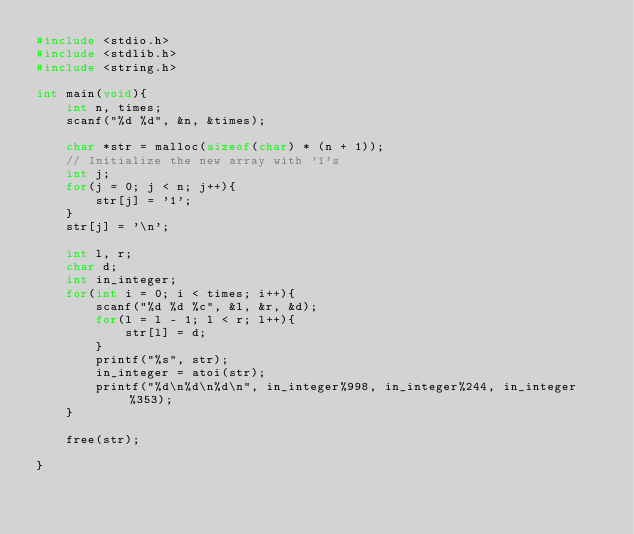<code> <loc_0><loc_0><loc_500><loc_500><_C_>#include <stdio.h>
#include <stdlib.h>
#include <string.h>

int main(void){
    int n, times;
    scanf("%d %d", &n, &times);

    char *str = malloc(sizeof(char) * (n + 1));
    // Initialize the new array with '1's
    int j;
    for(j = 0; j < n; j++){
        str[j] = '1';
    }
    str[j] = '\n';

    int l, r;
    char d;
    int in_integer;
    for(int i = 0; i < times; i++){
        scanf("%d %d %c", &l, &r, &d);
        for(l = l - 1; l < r; l++){
            str[l] = d;
        }
        printf("%s", str);
        in_integer = atoi(str);
        printf("%d\n%d\n%d\n", in_integer%998, in_integer%244, in_integer%353);
    }

    free(str);

}    


</code> 